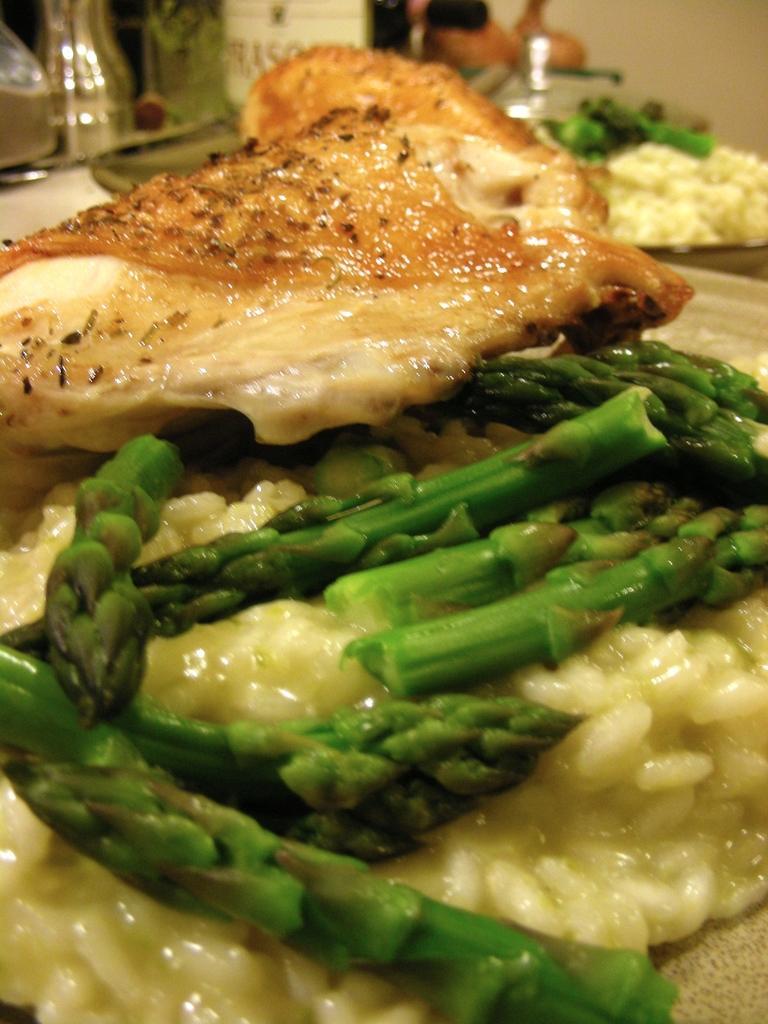Describe this image in one or two sentences. In this image, we can see some food items. 